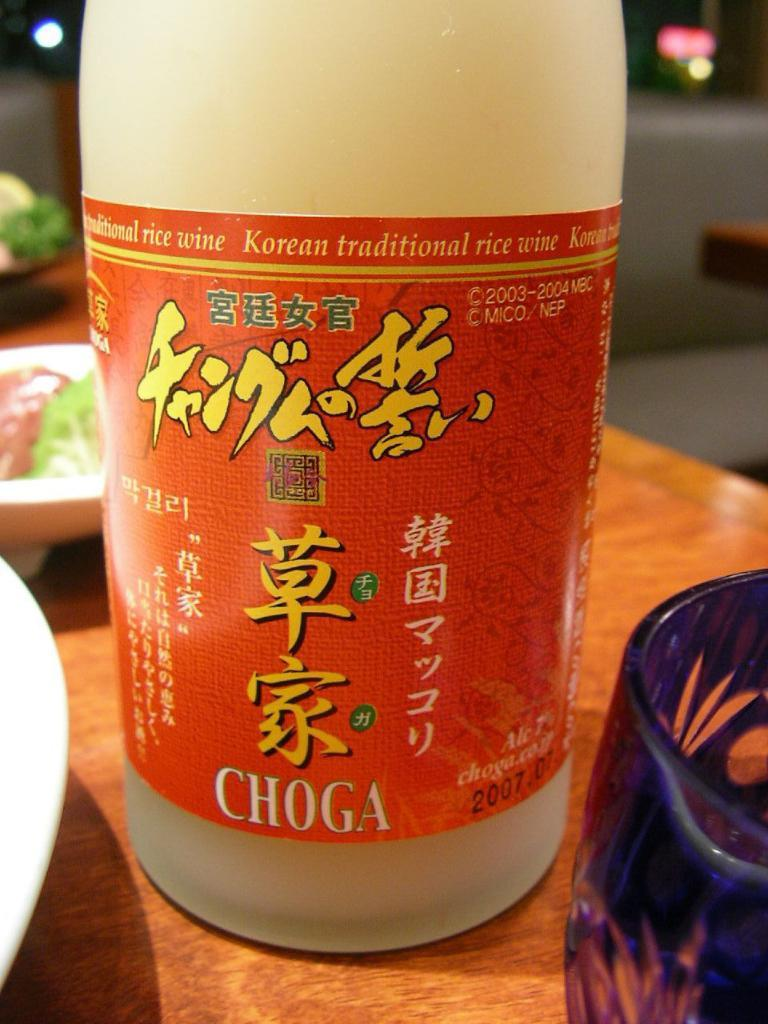<image>
Relay a brief, clear account of the picture shown. A plastic bottle of traditional Korean rice wine. 